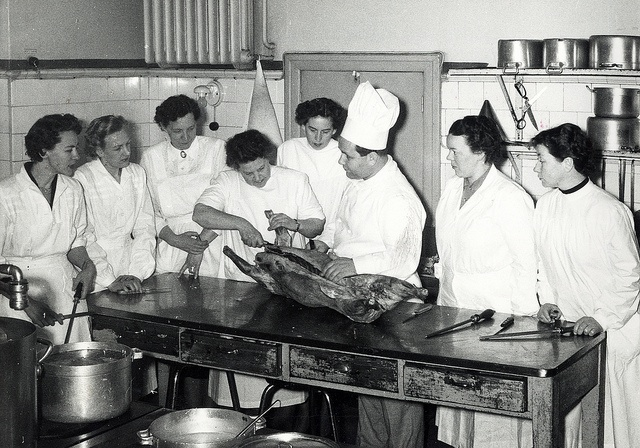Describe the objects in this image and their specific colors. I can see people in gray, lightgray, black, and darkgray tones, people in gray, white, darkgray, and black tones, people in gray, white, black, and darkgray tones, people in gray, lightgray, darkgray, and black tones, and people in gray, lightgray, darkgray, and black tones in this image. 